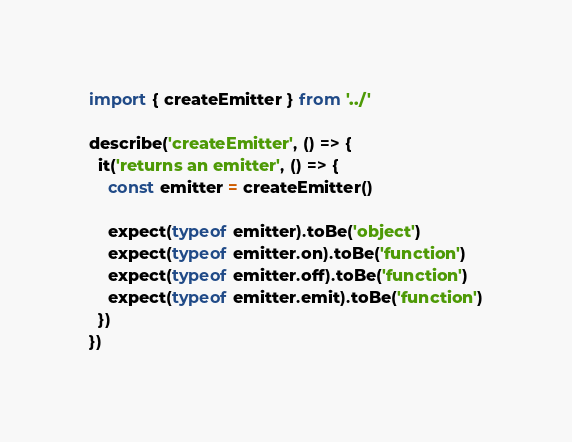Convert code to text. <code><loc_0><loc_0><loc_500><loc_500><_TypeScript_>import { createEmitter } from '../'

describe('createEmitter', () => {
  it('returns an emitter', () => {
    const emitter = createEmitter()

    expect(typeof emitter).toBe('object')
    expect(typeof emitter.on).toBe('function')
    expect(typeof emitter.off).toBe('function')
    expect(typeof emitter.emit).toBe('function')
  })
})
</code> 